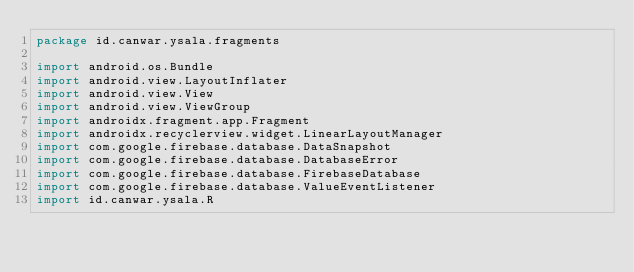<code> <loc_0><loc_0><loc_500><loc_500><_Kotlin_>package id.canwar.ysala.fragments

import android.os.Bundle
import android.view.LayoutInflater
import android.view.View
import android.view.ViewGroup
import androidx.fragment.app.Fragment
import androidx.recyclerview.widget.LinearLayoutManager
import com.google.firebase.database.DataSnapshot
import com.google.firebase.database.DatabaseError
import com.google.firebase.database.FirebaseDatabase
import com.google.firebase.database.ValueEventListener
import id.canwar.ysala.R</code> 